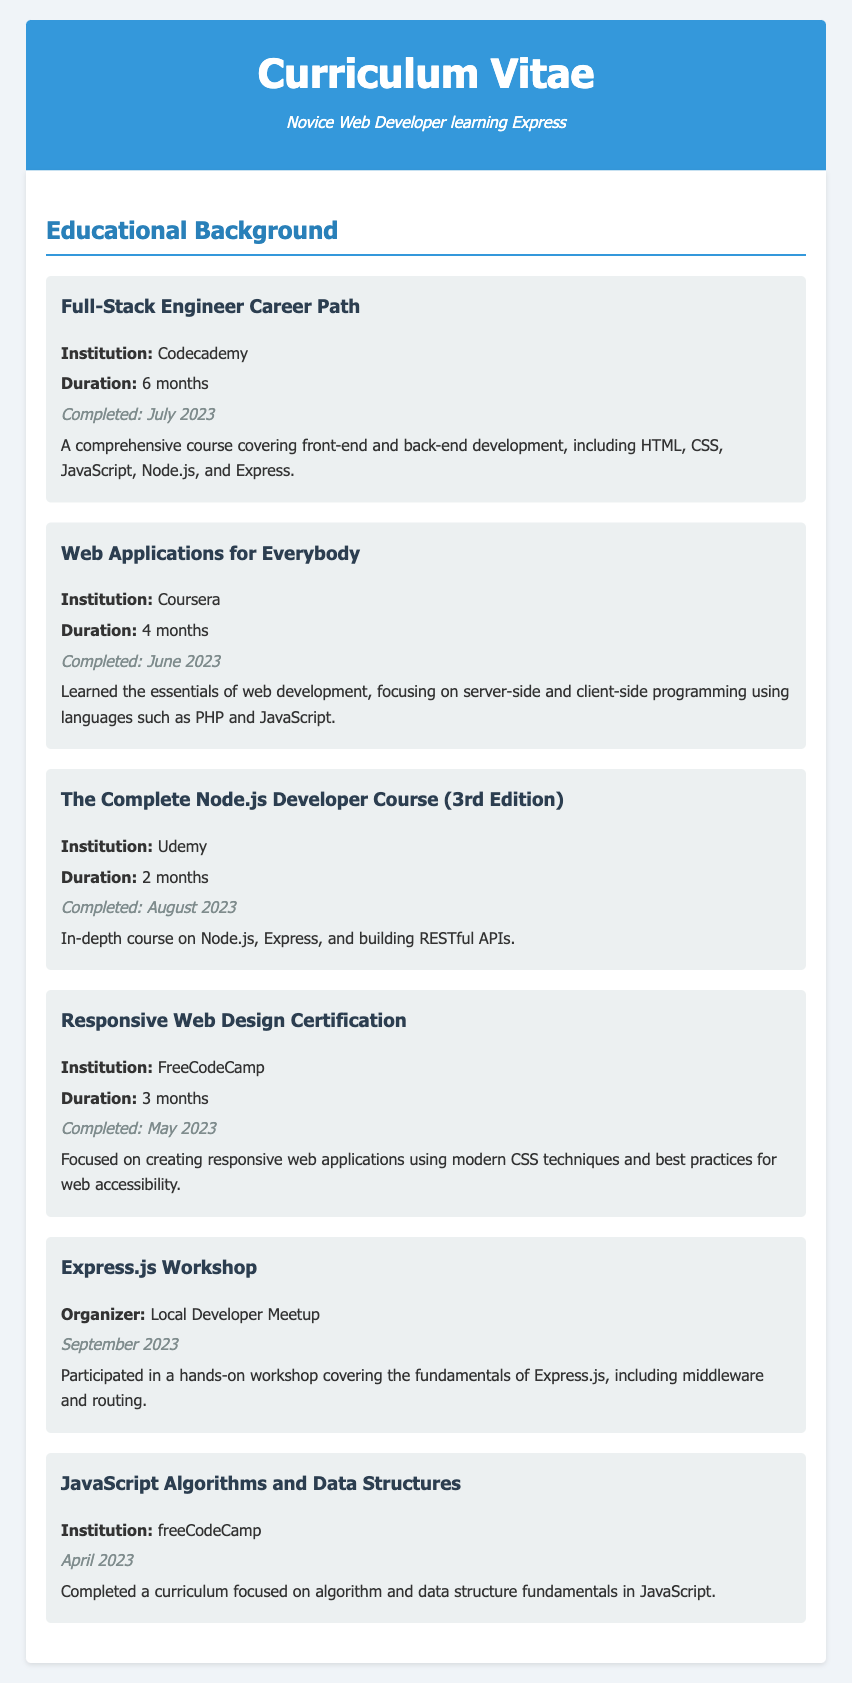What is the longest course duration listed? The longest duration among the courses listed is the Full-Stack Engineer Career Path, which lasted 6 months.
Answer: 6 months Who is the organizer of the Express.js Workshop? The Express.js Workshop was organized by the Local Developer Meetup.
Answer: Local Developer Meetup When was the Responsive Web Design Certification completed? The Responsive Web Design Certification was completed in May 2023.
Answer: May 2023 What programming languages were focused on in the Web Applications for Everybody course? The course emphasized server-side and client-side programming using PHP and JavaScript.
Answer: PHP and JavaScript Which institution offers the course on JavaScript Algorithms and Data Structures? The institution offering the JavaScript Algorithms and Data Structures course is freeCodeCamp.
Answer: freeCodeCamp How many months did the course The Complete Node.js Developer Course (3rd Edition) last? The duration of The Complete Node.js Developer Course (3rd Edition) was 2 months.
Answer: 2 months What type of certification did the individual obtain from FreeCodeCamp? The individual obtained a certification in Responsive Web Design.
Answer: Responsive Web Design What is the primary focus of the Full-Stack Engineer Career Path? The course covers front-end and back-end development including HTML, CSS, JavaScript, Node.js, and Express.
Answer: Front-end and back-end development 